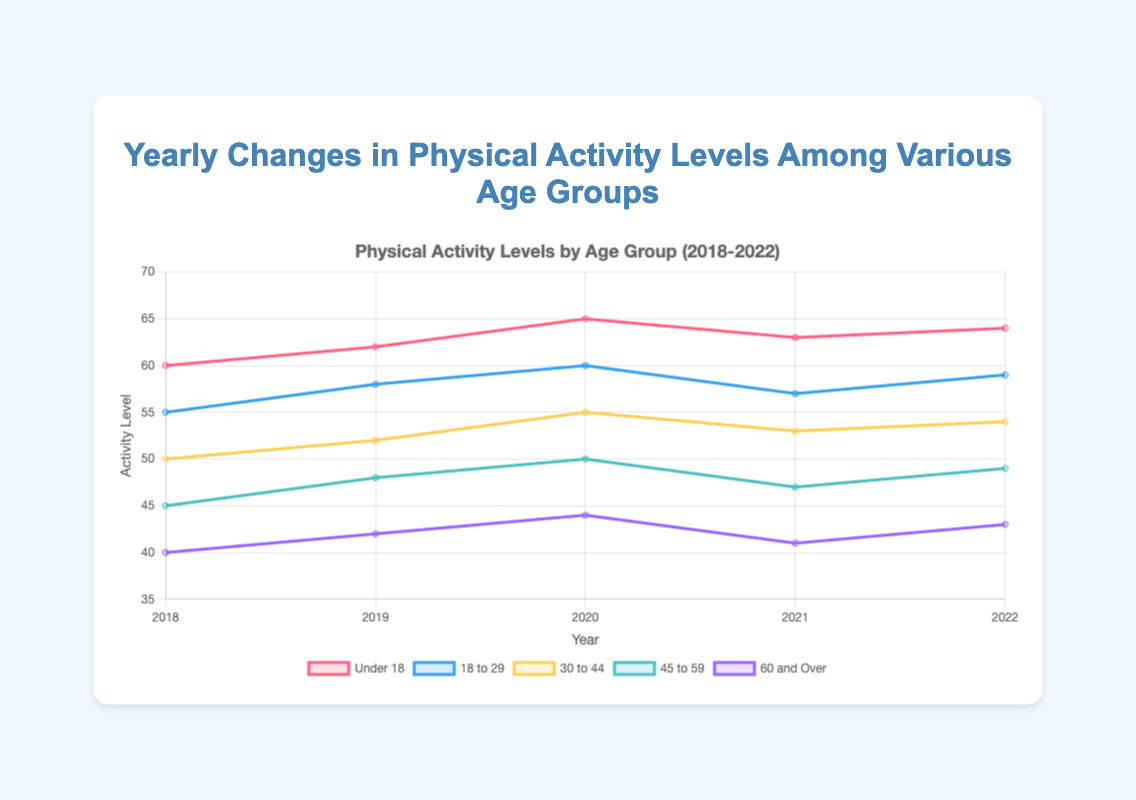What's the overall trend for the 'Under 18' age group from 2018 to 2022? The trend can be observed by looking at the data points for 'Under 18': 60 in 2018, 62 in 2019, 65 in 2020, 63 in 2021, and 64 in 2022. Initially, there is an increase from 2018 to 2020, followed by a slight decrease in 2021 and a minor increase again in 2022. So, the overall trend shows increasing activity levels with minor fluctuations.
Answer: Increasing with fluctuations Which age group showed the most significant increase in physical activity levels from 2018 to 2022? By calculating the difference between 2022 and 2018 for each age group: 'Under 18' increased by 4 (64-60), '18 to 29' by 4 (59-55), '30 to 44' by 4 (54-50), '45 to 59' by 4 (49-45), and '60 and Over' by 3 (43-40). All groups except '60 and Over' increased by 4, making it a tie for the largest increase.
Answer: Tie among all groups but '60 and Over' Which year had the lowest physical activity level for the '45 to 59' age group? By comparing the '45 to 59' data points: 45 in 2018, 48 in 2019, 50 in 2020, 47 in 2021, and 49 in 2022. The lowest activity level is 45, occurring in 2018.
Answer: 2018 What is the average physical activity level for the '30 to 44' age group over the five years? Sum the data points for '30 to 44' and divide by 5: (50 + 52 + 55 + 53 + 54) / 5 = 264 / 5 = 52.8.
Answer: 52.8 Between which two consecutive years did the '18 to 29' age group experience the largest decrease in physical activity levels? By calculating the year-to-year differences: 2018-2019 (+3), 2019-2020 (+2), 2020-2021 (-3), 2021-2022 (+2). The largest decrease is from 2020 to 2021, with a decrease of 3.
Answer: 2020 to 2021 Which age group had the most stable physical activity level in terms of the smallest variance in the data from 2018 to 2022? Examine the variance (calculated as the average of squared differences from the mean) for each age group. 'Under 18' (2.24), '18 to 29' (2.24), '30 to 44' (2.24), '45 to 59' (2.24), '60 and Over' (2.16). The smallest variance is for the '60 and Over' group.
Answer: 60 and Over How did the physical activity levels for the '60 and Over' age group change from 2019 to 2020? The data points for the '60 and Over' age group are 42 in 2019 and 44 in 2020, resulting in an increase of 2 (44 - 42).
Answer: Increased by 2 What is the median physical activity level for the '45 to 59' age group over the five years? List the data points for '45 to 59': 45, 48, 50, 47, 49. Sorting them in ascending order: 45, 47, 48, 49, 50. The median is the middle value, which is 48.
Answer: 48 